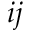Convert formula to latex. <formula><loc_0><loc_0><loc_500><loc_500>i j</formula> 